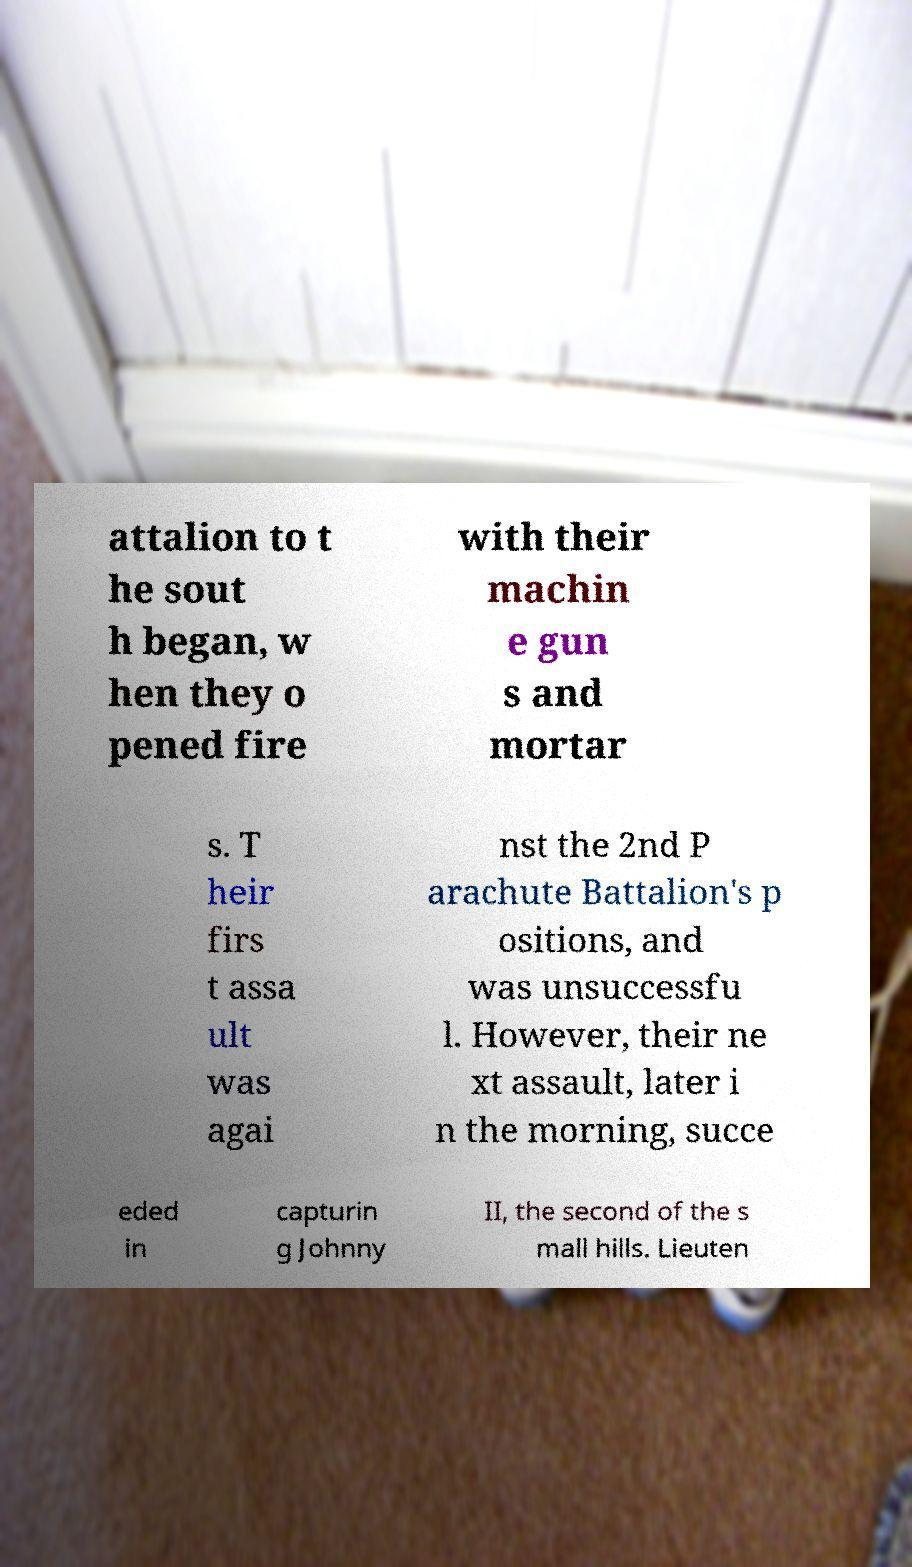What messages or text are displayed in this image? I need them in a readable, typed format. attalion to t he sout h began, w hen they o pened fire with their machin e gun s and mortar s. T heir firs t assa ult was agai nst the 2nd P arachute Battalion's p ositions, and was unsuccessfu l. However, their ne xt assault, later i n the morning, succe eded in capturin g Johnny II, the second of the s mall hills. Lieuten 